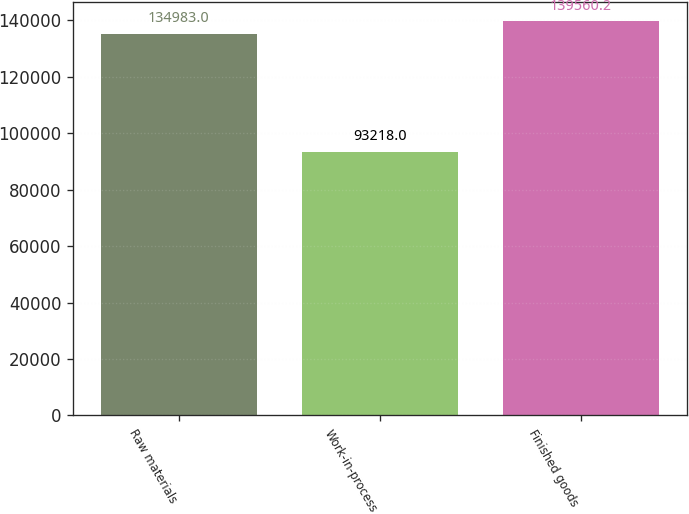Convert chart to OTSL. <chart><loc_0><loc_0><loc_500><loc_500><bar_chart><fcel>Raw materials<fcel>Work-in-process<fcel>Finished goods<nl><fcel>134983<fcel>93218<fcel>139560<nl></chart> 